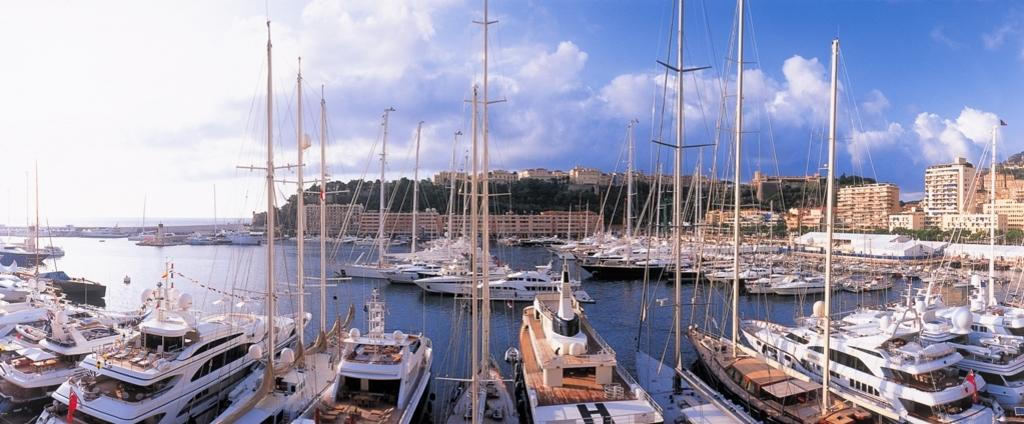What is the main subject of the image? The main subject of the image is many boats. What features do the boats have? The boats have poles and ropes. Where are the boats located? The boats are on the water. What can be seen in the background of the image? There are buildings, trees, and the sky visible in the background of the image. What is the condition of the sky in the image? The sky has clouds in it. What type of zephyr can be seen interacting with the boats in the image? There is no zephyr present in the image, and therefore no such interaction can be observed. What activity are the boats participating in, as seen in the image? The image does not show any specific activity involving the boats; they are simply on the water with their poles and ropes. 